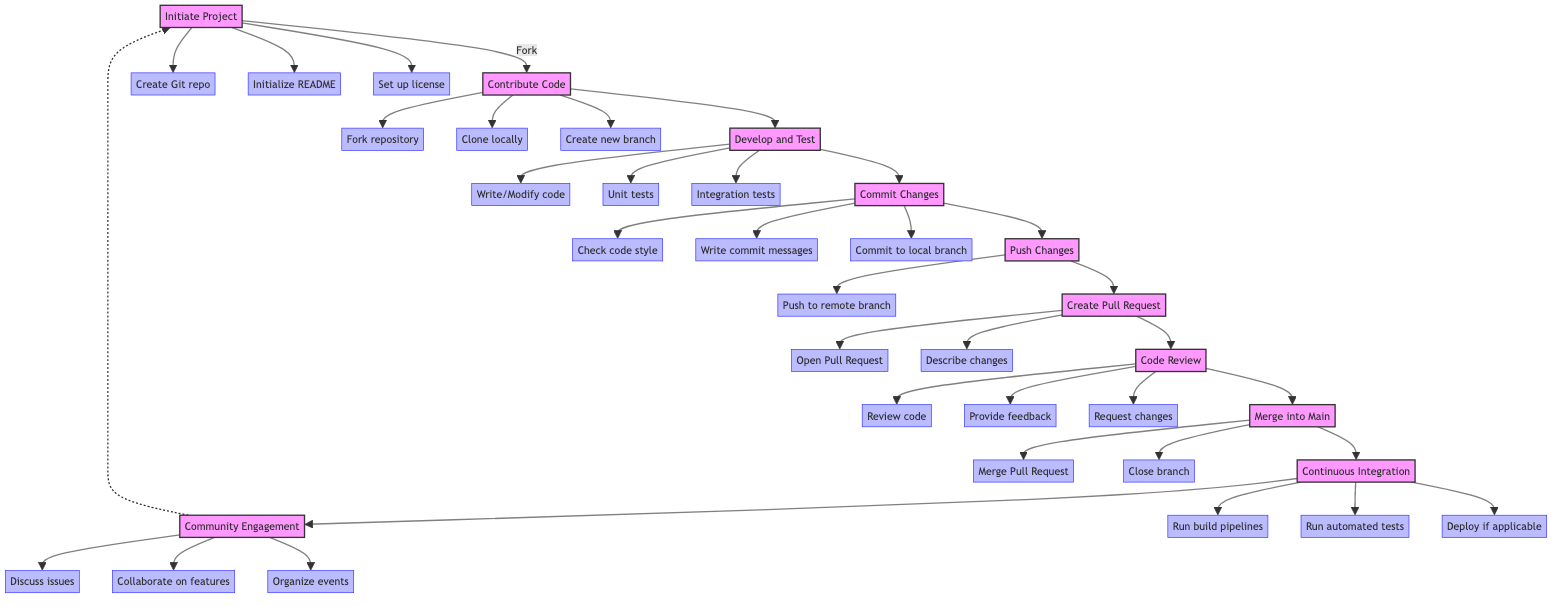What is the first step in the development workflow? The first step in the diagram is labeled as "Initiate Project", which starts the workflow.
Answer: Initiate Project How many main steps are there in the workflow? Counting the nodes in the diagram, there are ten main steps: Initiate Project, Contribute Code, Develop and Test, Commit Changes, Push Changes, Create Pull Request, Code Review, Merge into Main, Continuous Integration, and Community Engagement.
Answer: Ten What action follows "Create Pull Request"? Following "Create Pull Request", the next step in the workflow is "Code Review".
Answer: Code Review What is the last action in the workflow? The final action depicted in the diagram is "Community Engagement".
Answer: Community Engagement Which step involves committing changes to the local repository? The step that involves committing changes to the local repository is "Commit Changes".
Answer: Commit Changes What are the actions involved in "Develop and Test"? The actions involved in "Develop and Test" are: Write/Modify code, Unit tests, and Integration tests.
Answer: Write/Modify code, Unit tests, Integration tests How does the workflow loop back after "Community Engagement"? After "Community Engagement", the workflow loops back to "Initiate Project", indicating a cycle of continuous improvement.
Answer: Initiate Project What is the transition from "Code Review" to "Merge into Main"? The transition from "Code Review" to "Merge into Main" occurs after the review is successful, leading to the merging of approved changes into the main branch.
Answer: Merge into Main What happens during "Continuous Integration"? During "Continuous Integration", the actions are: Run build pipelines, Run automated tests, and Deploy if applicable.
Answer: Run build pipelines, Run automated tests, Deploy if applicable 